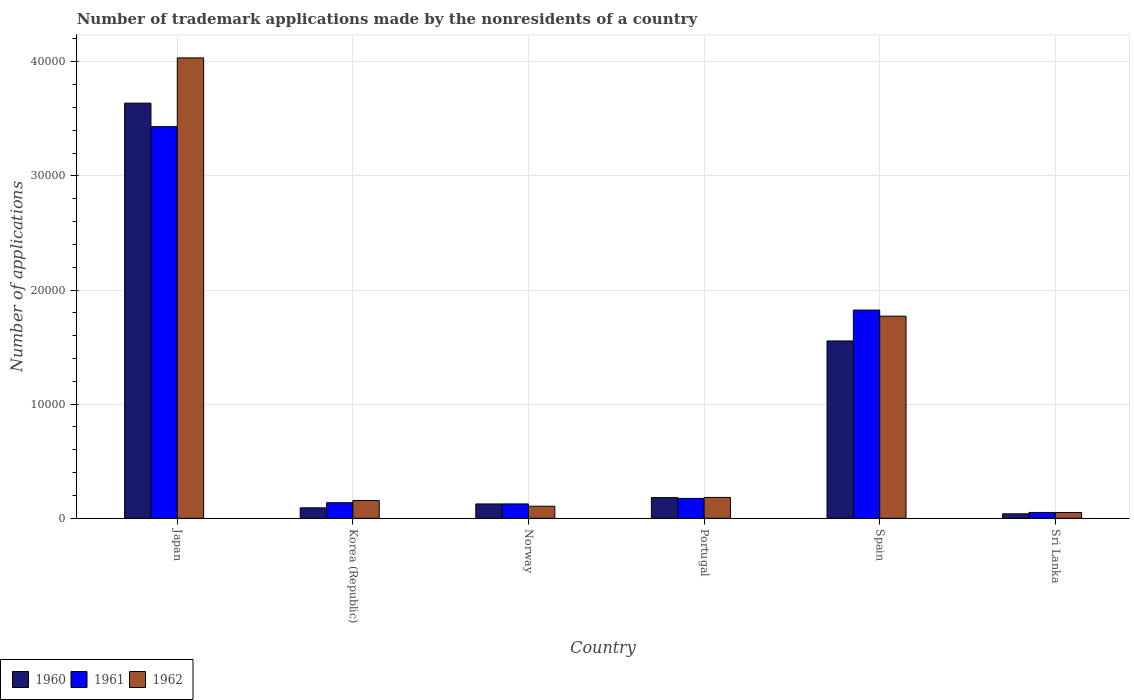Are the number of bars per tick equal to the number of legend labels?
Ensure brevity in your answer.  Yes. What is the number of trademark applications made by the nonresidents in 1960 in Korea (Republic)?
Provide a short and direct response. 916. Across all countries, what is the maximum number of trademark applications made by the nonresidents in 1961?
Your answer should be compact. 3.43e+04. Across all countries, what is the minimum number of trademark applications made by the nonresidents in 1962?
Offer a very short reply. 506. In which country was the number of trademark applications made by the nonresidents in 1960 minimum?
Your answer should be very brief. Sri Lanka. What is the total number of trademark applications made by the nonresidents in 1960 in the graph?
Give a very brief answer. 5.63e+04. What is the difference between the number of trademark applications made by the nonresidents in 1960 in Portugal and that in Sri Lanka?
Your answer should be compact. 1420. What is the difference between the number of trademark applications made by the nonresidents in 1960 in Sri Lanka and the number of trademark applications made by the nonresidents in 1961 in Japan?
Your response must be concise. -3.39e+04. What is the average number of trademark applications made by the nonresidents in 1962 per country?
Offer a terse response. 1.05e+04. What is the difference between the number of trademark applications made by the nonresidents of/in 1962 and number of trademark applications made by the nonresidents of/in 1961 in Norway?
Provide a short and direct response. -203. In how many countries, is the number of trademark applications made by the nonresidents in 1961 greater than 26000?
Ensure brevity in your answer.  1. What is the ratio of the number of trademark applications made by the nonresidents in 1961 in Norway to that in Portugal?
Your answer should be compact. 0.72. Is the number of trademark applications made by the nonresidents in 1962 in Portugal less than that in Spain?
Ensure brevity in your answer.  Yes. What is the difference between the highest and the second highest number of trademark applications made by the nonresidents in 1962?
Your answer should be compact. -1.59e+04. What is the difference between the highest and the lowest number of trademark applications made by the nonresidents in 1962?
Ensure brevity in your answer.  3.98e+04. In how many countries, is the number of trademark applications made by the nonresidents in 1960 greater than the average number of trademark applications made by the nonresidents in 1960 taken over all countries?
Give a very brief answer. 2. Is it the case that in every country, the sum of the number of trademark applications made by the nonresidents in 1962 and number of trademark applications made by the nonresidents in 1960 is greater than the number of trademark applications made by the nonresidents in 1961?
Keep it short and to the point. Yes. Are the values on the major ticks of Y-axis written in scientific E-notation?
Keep it short and to the point. No. What is the title of the graph?
Your answer should be very brief. Number of trademark applications made by the nonresidents of a country. What is the label or title of the X-axis?
Keep it short and to the point. Country. What is the label or title of the Y-axis?
Provide a succinct answer. Number of applications. What is the Number of applications in 1960 in Japan?
Your answer should be compact. 3.64e+04. What is the Number of applications in 1961 in Japan?
Ensure brevity in your answer.  3.43e+04. What is the Number of applications of 1962 in Japan?
Provide a succinct answer. 4.03e+04. What is the Number of applications in 1960 in Korea (Republic)?
Give a very brief answer. 916. What is the Number of applications in 1961 in Korea (Republic)?
Provide a succinct answer. 1363. What is the Number of applications in 1962 in Korea (Republic)?
Give a very brief answer. 1554. What is the Number of applications of 1960 in Norway?
Give a very brief answer. 1255. What is the Number of applications of 1961 in Norway?
Make the answer very short. 1258. What is the Number of applications of 1962 in Norway?
Give a very brief answer. 1055. What is the Number of applications of 1960 in Portugal?
Give a very brief answer. 1811. What is the Number of applications of 1961 in Portugal?
Keep it short and to the point. 1740. What is the Number of applications of 1962 in Portugal?
Your response must be concise. 1828. What is the Number of applications of 1960 in Spain?
Offer a terse response. 1.55e+04. What is the Number of applications in 1961 in Spain?
Provide a succinct answer. 1.82e+04. What is the Number of applications in 1962 in Spain?
Ensure brevity in your answer.  1.77e+04. What is the Number of applications of 1960 in Sri Lanka?
Provide a short and direct response. 391. What is the Number of applications in 1961 in Sri Lanka?
Your response must be concise. 510. What is the Number of applications in 1962 in Sri Lanka?
Your response must be concise. 506. Across all countries, what is the maximum Number of applications of 1960?
Give a very brief answer. 3.64e+04. Across all countries, what is the maximum Number of applications of 1961?
Offer a very short reply. 3.43e+04. Across all countries, what is the maximum Number of applications of 1962?
Offer a terse response. 4.03e+04. Across all countries, what is the minimum Number of applications in 1960?
Make the answer very short. 391. Across all countries, what is the minimum Number of applications in 1961?
Your response must be concise. 510. Across all countries, what is the minimum Number of applications of 1962?
Give a very brief answer. 506. What is the total Number of applications of 1960 in the graph?
Keep it short and to the point. 5.63e+04. What is the total Number of applications of 1961 in the graph?
Keep it short and to the point. 5.74e+04. What is the total Number of applications in 1962 in the graph?
Provide a short and direct response. 6.30e+04. What is the difference between the Number of applications of 1960 in Japan and that in Korea (Republic)?
Keep it short and to the point. 3.55e+04. What is the difference between the Number of applications in 1961 in Japan and that in Korea (Republic)?
Keep it short and to the point. 3.30e+04. What is the difference between the Number of applications of 1962 in Japan and that in Korea (Republic)?
Offer a terse response. 3.88e+04. What is the difference between the Number of applications in 1960 in Japan and that in Norway?
Your response must be concise. 3.51e+04. What is the difference between the Number of applications in 1961 in Japan and that in Norway?
Keep it short and to the point. 3.31e+04. What is the difference between the Number of applications of 1962 in Japan and that in Norway?
Make the answer very short. 3.93e+04. What is the difference between the Number of applications of 1960 in Japan and that in Portugal?
Keep it short and to the point. 3.46e+04. What is the difference between the Number of applications of 1961 in Japan and that in Portugal?
Give a very brief answer. 3.26e+04. What is the difference between the Number of applications in 1962 in Japan and that in Portugal?
Offer a very short reply. 3.85e+04. What is the difference between the Number of applications of 1960 in Japan and that in Spain?
Your answer should be very brief. 2.08e+04. What is the difference between the Number of applications in 1961 in Japan and that in Spain?
Your answer should be very brief. 1.61e+04. What is the difference between the Number of applications of 1962 in Japan and that in Spain?
Your response must be concise. 2.26e+04. What is the difference between the Number of applications in 1960 in Japan and that in Sri Lanka?
Offer a very short reply. 3.60e+04. What is the difference between the Number of applications in 1961 in Japan and that in Sri Lanka?
Give a very brief answer. 3.38e+04. What is the difference between the Number of applications of 1962 in Japan and that in Sri Lanka?
Offer a very short reply. 3.98e+04. What is the difference between the Number of applications of 1960 in Korea (Republic) and that in Norway?
Make the answer very short. -339. What is the difference between the Number of applications of 1961 in Korea (Republic) and that in Norway?
Your response must be concise. 105. What is the difference between the Number of applications of 1962 in Korea (Republic) and that in Norway?
Ensure brevity in your answer.  499. What is the difference between the Number of applications in 1960 in Korea (Republic) and that in Portugal?
Give a very brief answer. -895. What is the difference between the Number of applications in 1961 in Korea (Republic) and that in Portugal?
Provide a short and direct response. -377. What is the difference between the Number of applications of 1962 in Korea (Republic) and that in Portugal?
Offer a very short reply. -274. What is the difference between the Number of applications in 1960 in Korea (Republic) and that in Spain?
Your answer should be compact. -1.46e+04. What is the difference between the Number of applications in 1961 in Korea (Republic) and that in Spain?
Ensure brevity in your answer.  -1.69e+04. What is the difference between the Number of applications in 1962 in Korea (Republic) and that in Spain?
Your response must be concise. -1.62e+04. What is the difference between the Number of applications in 1960 in Korea (Republic) and that in Sri Lanka?
Provide a short and direct response. 525. What is the difference between the Number of applications in 1961 in Korea (Republic) and that in Sri Lanka?
Ensure brevity in your answer.  853. What is the difference between the Number of applications of 1962 in Korea (Republic) and that in Sri Lanka?
Give a very brief answer. 1048. What is the difference between the Number of applications in 1960 in Norway and that in Portugal?
Your answer should be very brief. -556. What is the difference between the Number of applications of 1961 in Norway and that in Portugal?
Offer a very short reply. -482. What is the difference between the Number of applications in 1962 in Norway and that in Portugal?
Offer a very short reply. -773. What is the difference between the Number of applications of 1960 in Norway and that in Spain?
Offer a very short reply. -1.43e+04. What is the difference between the Number of applications of 1961 in Norway and that in Spain?
Your response must be concise. -1.70e+04. What is the difference between the Number of applications of 1962 in Norway and that in Spain?
Give a very brief answer. -1.67e+04. What is the difference between the Number of applications of 1960 in Norway and that in Sri Lanka?
Make the answer very short. 864. What is the difference between the Number of applications of 1961 in Norway and that in Sri Lanka?
Provide a succinct answer. 748. What is the difference between the Number of applications of 1962 in Norway and that in Sri Lanka?
Give a very brief answer. 549. What is the difference between the Number of applications in 1960 in Portugal and that in Spain?
Your answer should be compact. -1.37e+04. What is the difference between the Number of applications in 1961 in Portugal and that in Spain?
Your answer should be compact. -1.65e+04. What is the difference between the Number of applications of 1962 in Portugal and that in Spain?
Your answer should be very brief. -1.59e+04. What is the difference between the Number of applications in 1960 in Portugal and that in Sri Lanka?
Make the answer very short. 1420. What is the difference between the Number of applications of 1961 in Portugal and that in Sri Lanka?
Make the answer very short. 1230. What is the difference between the Number of applications of 1962 in Portugal and that in Sri Lanka?
Your response must be concise. 1322. What is the difference between the Number of applications of 1960 in Spain and that in Sri Lanka?
Offer a very short reply. 1.51e+04. What is the difference between the Number of applications of 1961 in Spain and that in Sri Lanka?
Provide a short and direct response. 1.77e+04. What is the difference between the Number of applications of 1962 in Spain and that in Sri Lanka?
Make the answer very short. 1.72e+04. What is the difference between the Number of applications of 1960 in Japan and the Number of applications of 1961 in Korea (Republic)?
Ensure brevity in your answer.  3.50e+04. What is the difference between the Number of applications in 1960 in Japan and the Number of applications in 1962 in Korea (Republic)?
Offer a terse response. 3.48e+04. What is the difference between the Number of applications in 1961 in Japan and the Number of applications in 1962 in Korea (Republic)?
Ensure brevity in your answer.  3.28e+04. What is the difference between the Number of applications of 1960 in Japan and the Number of applications of 1961 in Norway?
Your answer should be very brief. 3.51e+04. What is the difference between the Number of applications in 1960 in Japan and the Number of applications in 1962 in Norway?
Your answer should be compact. 3.53e+04. What is the difference between the Number of applications of 1961 in Japan and the Number of applications of 1962 in Norway?
Provide a succinct answer. 3.33e+04. What is the difference between the Number of applications of 1960 in Japan and the Number of applications of 1961 in Portugal?
Ensure brevity in your answer.  3.46e+04. What is the difference between the Number of applications of 1960 in Japan and the Number of applications of 1962 in Portugal?
Provide a succinct answer. 3.45e+04. What is the difference between the Number of applications of 1961 in Japan and the Number of applications of 1962 in Portugal?
Keep it short and to the point. 3.25e+04. What is the difference between the Number of applications of 1960 in Japan and the Number of applications of 1961 in Spain?
Your response must be concise. 1.81e+04. What is the difference between the Number of applications of 1960 in Japan and the Number of applications of 1962 in Spain?
Give a very brief answer. 1.87e+04. What is the difference between the Number of applications in 1961 in Japan and the Number of applications in 1962 in Spain?
Ensure brevity in your answer.  1.66e+04. What is the difference between the Number of applications of 1960 in Japan and the Number of applications of 1961 in Sri Lanka?
Provide a succinct answer. 3.59e+04. What is the difference between the Number of applications of 1960 in Japan and the Number of applications of 1962 in Sri Lanka?
Offer a very short reply. 3.59e+04. What is the difference between the Number of applications in 1961 in Japan and the Number of applications in 1962 in Sri Lanka?
Provide a short and direct response. 3.38e+04. What is the difference between the Number of applications in 1960 in Korea (Republic) and the Number of applications in 1961 in Norway?
Ensure brevity in your answer.  -342. What is the difference between the Number of applications of 1960 in Korea (Republic) and the Number of applications of 1962 in Norway?
Keep it short and to the point. -139. What is the difference between the Number of applications of 1961 in Korea (Republic) and the Number of applications of 1962 in Norway?
Offer a very short reply. 308. What is the difference between the Number of applications of 1960 in Korea (Republic) and the Number of applications of 1961 in Portugal?
Provide a short and direct response. -824. What is the difference between the Number of applications of 1960 in Korea (Republic) and the Number of applications of 1962 in Portugal?
Make the answer very short. -912. What is the difference between the Number of applications of 1961 in Korea (Republic) and the Number of applications of 1962 in Portugal?
Make the answer very short. -465. What is the difference between the Number of applications of 1960 in Korea (Republic) and the Number of applications of 1961 in Spain?
Ensure brevity in your answer.  -1.73e+04. What is the difference between the Number of applications of 1960 in Korea (Republic) and the Number of applications of 1962 in Spain?
Your answer should be very brief. -1.68e+04. What is the difference between the Number of applications in 1961 in Korea (Republic) and the Number of applications in 1962 in Spain?
Make the answer very short. -1.63e+04. What is the difference between the Number of applications of 1960 in Korea (Republic) and the Number of applications of 1961 in Sri Lanka?
Ensure brevity in your answer.  406. What is the difference between the Number of applications of 1960 in Korea (Republic) and the Number of applications of 1962 in Sri Lanka?
Your answer should be very brief. 410. What is the difference between the Number of applications in 1961 in Korea (Republic) and the Number of applications in 1962 in Sri Lanka?
Offer a terse response. 857. What is the difference between the Number of applications of 1960 in Norway and the Number of applications of 1961 in Portugal?
Offer a very short reply. -485. What is the difference between the Number of applications in 1960 in Norway and the Number of applications in 1962 in Portugal?
Provide a succinct answer. -573. What is the difference between the Number of applications of 1961 in Norway and the Number of applications of 1962 in Portugal?
Offer a terse response. -570. What is the difference between the Number of applications of 1960 in Norway and the Number of applications of 1961 in Spain?
Offer a very short reply. -1.70e+04. What is the difference between the Number of applications in 1960 in Norway and the Number of applications in 1962 in Spain?
Keep it short and to the point. -1.65e+04. What is the difference between the Number of applications of 1961 in Norway and the Number of applications of 1962 in Spain?
Your answer should be compact. -1.65e+04. What is the difference between the Number of applications of 1960 in Norway and the Number of applications of 1961 in Sri Lanka?
Your answer should be compact. 745. What is the difference between the Number of applications of 1960 in Norway and the Number of applications of 1962 in Sri Lanka?
Provide a short and direct response. 749. What is the difference between the Number of applications of 1961 in Norway and the Number of applications of 1962 in Sri Lanka?
Make the answer very short. 752. What is the difference between the Number of applications of 1960 in Portugal and the Number of applications of 1961 in Spain?
Provide a short and direct response. -1.64e+04. What is the difference between the Number of applications in 1960 in Portugal and the Number of applications in 1962 in Spain?
Offer a very short reply. -1.59e+04. What is the difference between the Number of applications in 1961 in Portugal and the Number of applications in 1962 in Spain?
Your answer should be compact. -1.60e+04. What is the difference between the Number of applications of 1960 in Portugal and the Number of applications of 1961 in Sri Lanka?
Give a very brief answer. 1301. What is the difference between the Number of applications of 1960 in Portugal and the Number of applications of 1962 in Sri Lanka?
Give a very brief answer. 1305. What is the difference between the Number of applications in 1961 in Portugal and the Number of applications in 1962 in Sri Lanka?
Provide a short and direct response. 1234. What is the difference between the Number of applications in 1960 in Spain and the Number of applications in 1961 in Sri Lanka?
Provide a succinct answer. 1.50e+04. What is the difference between the Number of applications in 1960 in Spain and the Number of applications in 1962 in Sri Lanka?
Offer a very short reply. 1.50e+04. What is the difference between the Number of applications in 1961 in Spain and the Number of applications in 1962 in Sri Lanka?
Provide a short and direct response. 1.77e+04. What is the average Number of applications in 1960 per country?
Offer a terse response. 9381.17. What is the average Number of applications of 1961 per country?
Ensure brevity in your answer.  9572.5. What is the average Number of applications of 1962 per country?
Keep it short and to the point. 1.05e+04. What is the difference between the Number of applications of 1960 and Number of applications of 1961 in Japan?
Ensure brevity in your answer.  2057. What is the difference between the Number of applications of 1960 and Number of applications of 1962 in Japan?
Your answer should be compact. -3966. What is the difference between the Number of applications of 1961 and Number of applications of 1962 in Japan?
Your answer should be compact. -6023. What is the difference between the Number of applications of 1960 and Number of applications of 1961 in Korea (Republic)?
Give a very brief answer. -447. What is the difference between the Number of applications in 1960 and Number of applications in 1962 in Korea (Republic)?
Offer a terse response. -638. What is the difference between the Number of applications in 1961 and Number of applications in 1962 in Korea (Republic)?
Keep it short and to the point. -191. What is the difference between the Number of applications in 1960 and Number of applications in 1962 in Norway?
Provide a succinct answer. 200. What is the difference between the Number of applications of 1961 and Number of applications of 1962 in Norway?
Offer a very short reply. 203. What is the difference between the Number of applications of 1960 and Number of applications of 1961 in Portugal?
Make the answer very short. 71. What is the difference between the Number of applications of 1960 and Number of applications of 1962 in Portugal?
Provide a short and direct response. -17. What is the difference between the Number of applications of 1961 and Number of applications of 1962 in Portugal?
Offer a very short reply. -88. What is the difference between the Number of applications of 1960 and Number of applications of 1961 in Spain?
Make the answer very short. -2707. What is the difference between the Number of applications in 1960 and Number of applications in 1962 in Spain?
Provide a succinct answer. -2173. What is the difference between the Number of applications in 1961 and Number of applications in 1962 in Spain?
Offer a very short reply. 534. What is the difference between the Number of applications in 1960 and Number of applications in 1961 in Sri Lanka?
Give a very brief answer. -119. What is the difference between the Number of applications of 1960 and Number of applications of 1962 in Sri Lanka?
Your answer should be compact. -115. What is the ratio of the Number of applications in 1960 in Japan to that in Korea (Republic)?
Your response must be concise. 39.71. What is the ratio of the Number of applications of 1961 in Japan to that in Korea (Republic)?
Offer a very short reply. 25.18. What is the ratio of the Number of applications in 1962 in Japan to that in Korea (Republic)?
Provide a succinct answer. 25.96. What is the ratio of the Number of applications in 1960 in Japan to that in Norway?
Your answer should be compact. 28.99. What is the ratio of the Number of applications of 1961 in Japan to that in Norway?
Make the answer very short. 27.28. What is the ratio of the Number of applications in 1962 in Japan to that in Norway?
Give a very brief answer. 38.24. What is the ratio of the Number of applications of 1960 in Japan to that in Portugal?
Make the answer very short. 20.09. What is the ratio of the Number of applications in 1961 in Japan to that in Portugal?
Keep it short and to the point. 19.72. What is the ratio of the Number of applications in 1962 in Japan to that in Portugal?
Your answer should be very brief. 22.07. What is the ratio of the Number of applications in 1960 in Japan to that in Spain?
Provide a short and direct response. 2.34. What is the ratio of the Number of applications in 1961 in Japan to that in Spain?
Offer a very short reply. 1.88. What is the ratio of the Number of applications of 1962 in Japan to that in Spain?
Provide a succinct answer. 2.28. What is the ratio of the Number of applications in 1960 in Japan to that in Sri Lanka?
Your answer should be very brief. 93.04. What is the ratio of the Number of applications of 1961 in Japan to that in Sri Lanka?
Provide a short and direct response. 67.29. What is the ratio of the Number of applications of 1962 in Japan to that in Sri Lanka?
Your answer should be compact. 79.73. What is the ratio of the Number of applications of 1960 in Korea (Republic) to that in Norway?
Make the answer very short. 0.73. What is the ratio of the Number of applications in 1961 in Korea (Republic) to that in Norway?
Your answer should be very brief. 1.08. What is the ratio of the Number of applications in 1962 in Korea (Republic) to that in Norway?
Offer a very short reply. 1.47. What is the ratio of the Number of applications in 1960 in Korea (Republic) to that in Portugal?
Your answer should be very brief. 0.51. What is the ratio of the Number of applications in 1961 in Korea (Republic) to that in Portugal?
Your answer should be compact. 0.78. What is the ratio of the Number of applications of 1962 in Korea (Republic) to that in Portugal?
Your response must be concise. 0.85. What is the ratio of the Number of applications in 1960 in Korea (Republic) to that in Spain?
Keep it short and to the point. 0.06. What is the ratio of the Number of applications in 1961 in Korea (Republic) to that in Spain?
Your answer should be compact. 0.07. What is the ratio of the Number of applications of 1962 in Korea (Republic) to that in Spain?
Provide a succinct answer. 0.09. What is the ratio of the Number of applications of 1960 in Korea (Republic) to that in Sri Lanka?
Your answer should be very brief. 2.34. What is the ratio of the Number of applications in 1961 in Korea (Republic) to that in Sri Lanka?
Offer a very short reply. 2.67. What is the ratio of the Number of applications of 1962 in Korea (Republic) to that in Sri Lanka?
Ensure brevity in your answer.  3.07. What is the ratio of the Number of applications of 1960 in Norway to that in Portugal?
Give a very brief answer. 0.69. What is the ratio of the Number of applications of 1961 in Norway to that in Portugal?
Your answer should be compact. 0.72. What is the ratio of the Number of applications in 1962 in Norway to that in Portugal?
Provide a succinct answer. 0.58. What is the ratio of the Number of applications of 1960 in Norway to that in Spain?
Your answer should be very brief. 0.08. What is the ratio of the Number of applications in 1961 in Norway to that in Spain?
Give a very brief answer. 0.07. What is the ratio of the Number of applications in 1962 in Norway to that in Spain?
Offer a very short reply. 0.06. What is the ratio of the Number of applications of 1960 in Norway to that in Sri Lanka?
Offer a very short reply. 3.21. What is the ratio of the Number of applications of 1961 in Norway to that in Sri Lanka?
Give a very brief answer. 2.47. What is the ratio of the Number of applications in 1962 in Norway to that in Sri Lanka?
Provide a succinct answer. 2.08. What is the ratio of the Number of applications in 1960 in Portugal to that in Spain?
Your answer should be very brief. 0.12. What is the ratio of the Number of applications in 1961 in Portugal to that in Spain?
Provide a short and direct response. 0.1. What is the ratio of the Number of applications in 1962 in Portugal to that in Spain?
Provide a short and direct response. 0.1. What is the ratio of the Number of applications of 1960 in Portugal to that in Sri Lanka?
Your answer should be compact. 4.63. What is the ratio of the Number of applications of 1961 in Portugal to that in Sri Lanka?
Your answer should be compact. 3.41. What is the ratio of the Number of applications of 1962 in Portugal to that in Sri Lanka?
Ensure brevity in your answer.  3.61. What is the ratio of the Number of applications of 1960 in Spain to that in Sri Lanka?
Offer a very short reply. 39.74. What is the ratio of the Number of applications in 1961 in Spain to that in Sri Lanka?
Your answer should be compact. 35.77. What is the ratio of the Number of applications in 1962 in Spain to that in Sri Lanka?
Provide a succinct answer. 35. What is the difference between the highest and the second highest Number of applications of 1960?
Provide a short and direct response. 2.08e+04. What is the difference between the highest and the second highest Number of applications of 1961?
Ensure brevity in your answer.  1.61e+04. What is the difference between the highest and the second highest Number of applications of 1962?
Ensure brevity in your answer.  2.26e+04. What is the difference between the highest and the lowest Number of applications of 1960?
Offer a terse response. 3.60e+04. What is the difference between the highest and the lowest Number of applications in 1961?
Keep it short and to the point. 3.38e+04. What is the difference between the highest and the lowest Number of applications of 1962?
Keep it short and to the point. 3.98e+04. 